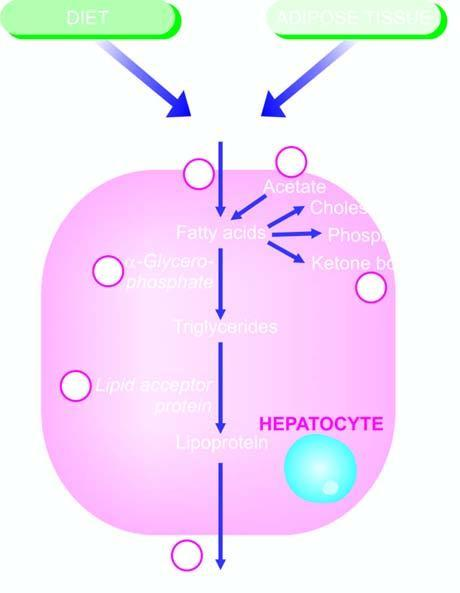how many steps defects in any of which can produce fatty liver by different etiologic agents?
Answer the question using a single word or phrase. Six 